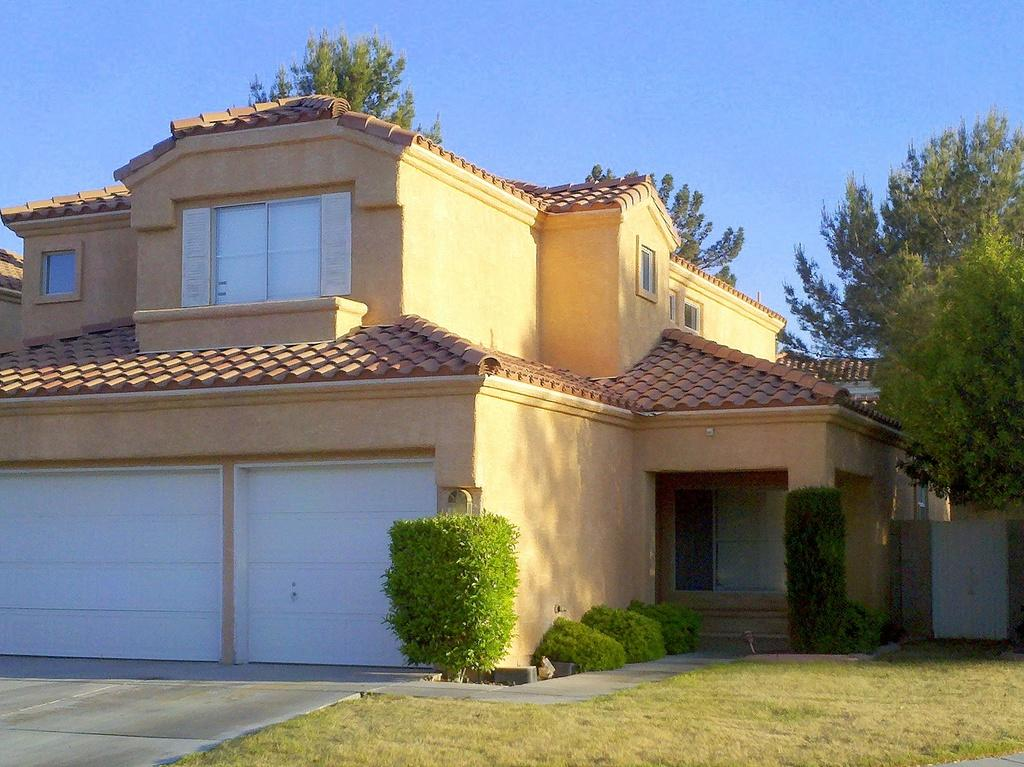What type of vegetation can be seen in the image? There is grass, shrubs, and trees in the image. What structures are present in the image? There is a garage and a house in the image. What color is the sky in the image? The sky is blue and serves as the background in the image. What type of account does the parent open for their child in the image? There is no mention of a parent or an account in the image; it features grass, shrubs, trees, a garage, and a house with a blue sky as the background. How many branches are visible on the tree in the image? There is no specific tree mentioned in the image, so it is impossible to determine the number of branches visible. 